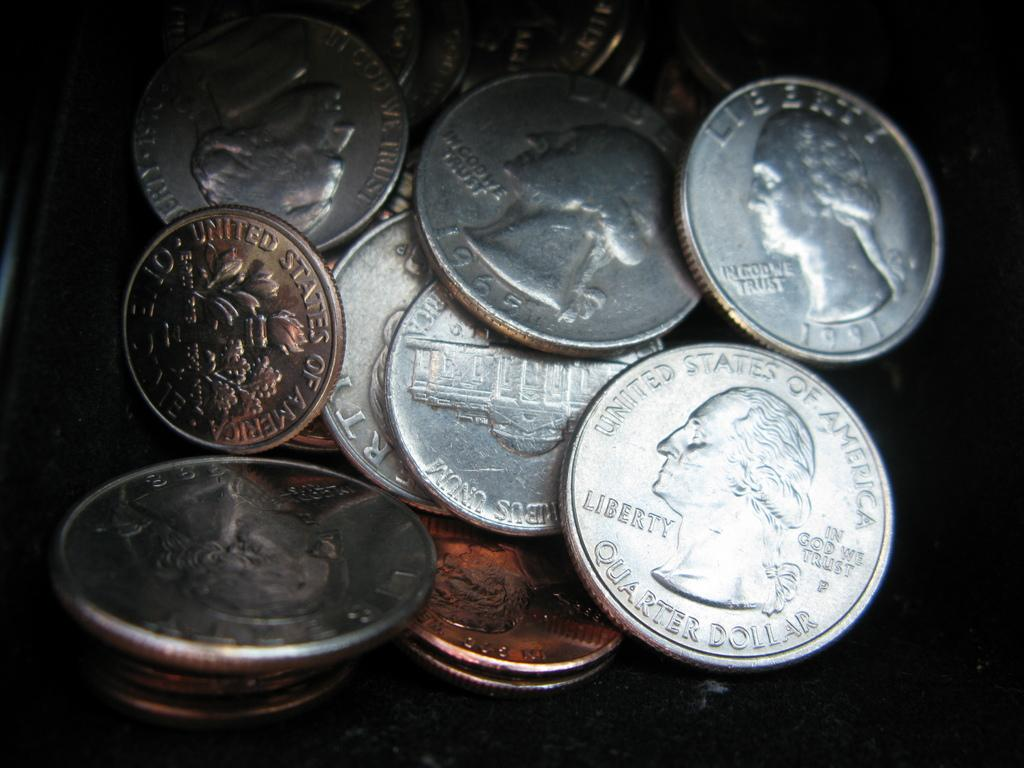<image>
Share a concise interpretation of the image provided. A pile of change with united states quarters that say liberty on them. 